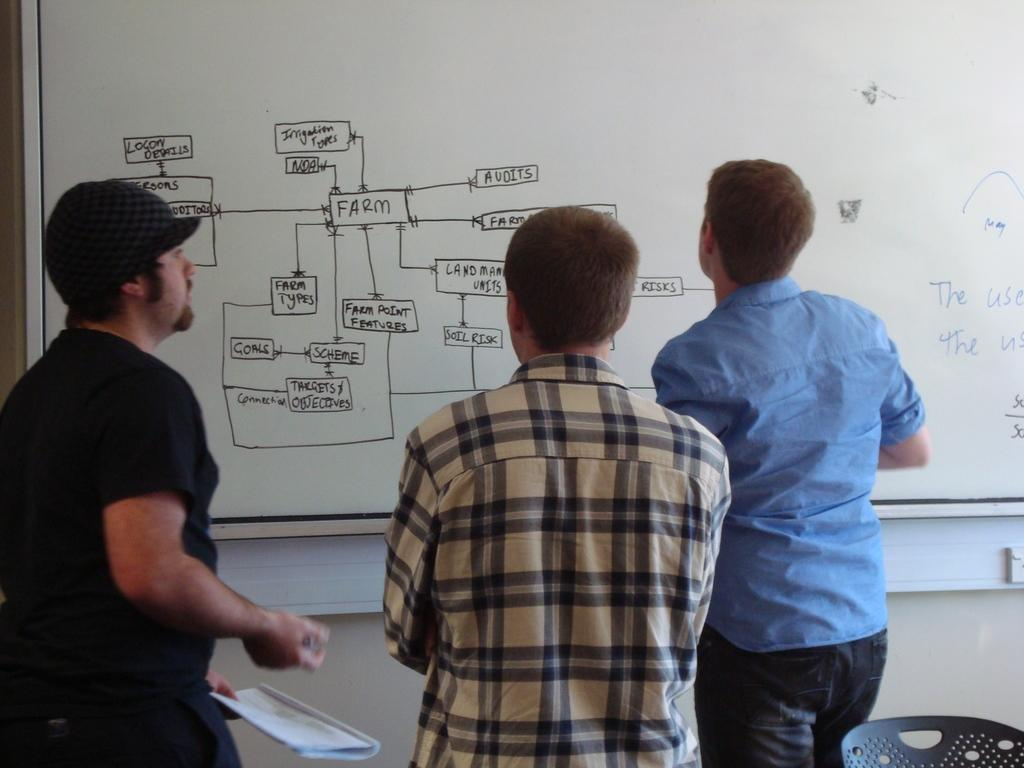<image>
Render a clear and concise summary of the photo. A group of men looking at a whiteboard with the Farm on it. 